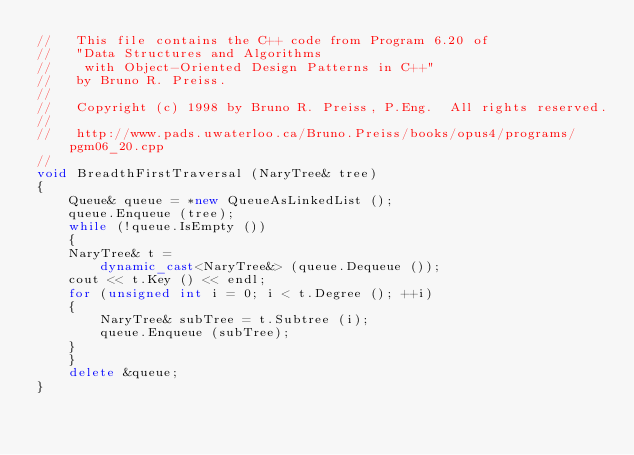Convert code to text. <code><loc_0><loc_0><loc_500><loc_500><_C++_>//   This file contains the C++ code from Program 6.20 of
//   "Data Structures and Algorithms
//    with Object-Oriented Design Patterns in C++"
//   by Bruno R. Preiss.
//
//   Copyright (c) 1998 by Bruno R. Preiss, P.Eng.  All rights reserved.
//
//   http://www.pads.uwaterloo.ca/Bruno.Preiss/books/opus4/programs/pgm06_20.cpp
//
void BreadthFirstTraversal (NaryTree& tree)
{
    Queue& queue = *new QueueAsLinkedList ();
    queue.Enqueue (tree);
    while (!queue.IsEmpty ())
    {
	NaryTree& t =
	    dynamic_cast<NaryTree&> (queue.Dequeue ());
	cout << t.Key () << endl;
	for (unsigned int i = 0; i < t.Degree (); ++i)
	{
	    NaryTree& subTree = t.Subtree (i);
	    queue.Enqueue (subTree);
	}
    }
    delete &queue;
}
</code> 